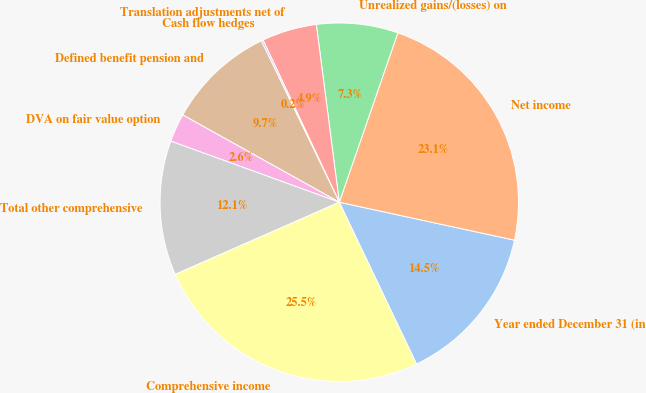Convert chart. <chart><loc_0><loc_0><loc_500><loc_500><pie_chart><fcel>Year ended December 31 (in<fcel>Net income<fcel>Unrealized gains/(losses) on<fcel>Translation adjustments net of<fcel>Cash flow hedges<fcel>Defined benefit pension and<fcel>DVA on fair value option<fcel>Total other comprehensive<fcel>Comprehensive income<nl><fcel>14.52%<fcel>23.1%<fcel>7.34%<fcel>4.95%<fcel>0.17%<fcel>9.74%<fcel>2.56%<fcel>12.13%<fcel>25.49%<nl></chart> 